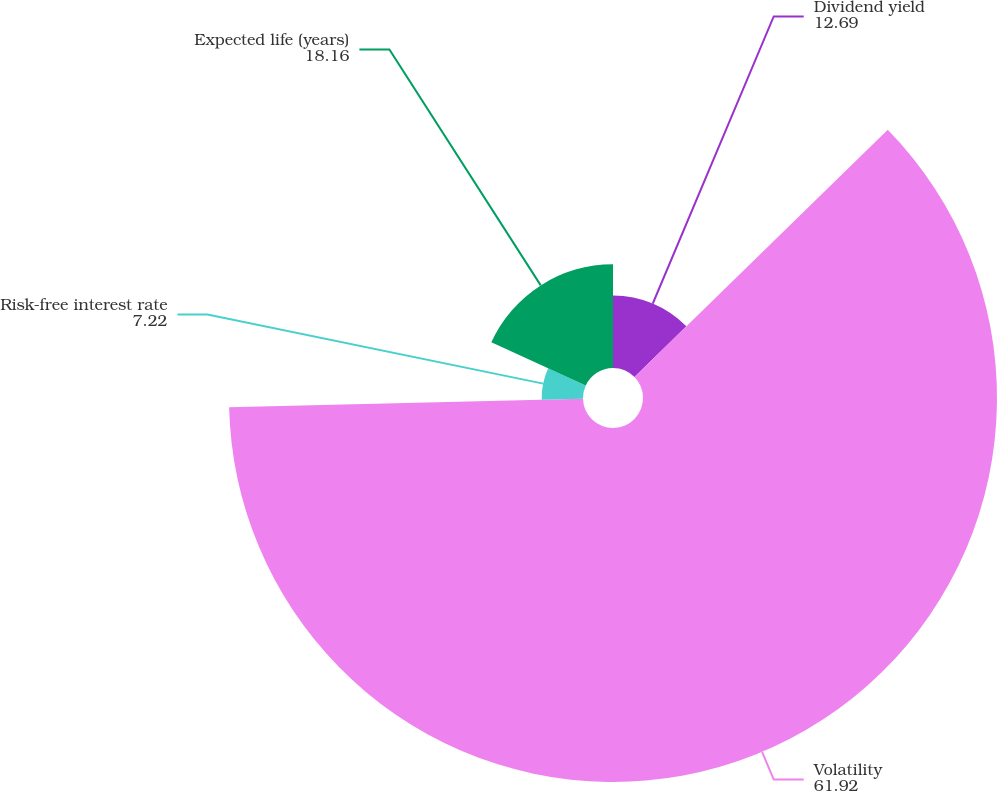Convert chart to OTSL. <chart><loc_0><loc_0><loc_500><loc_500><pie_chart><fcel>Dividend yield<fcel>Volatility<fcel>Risk-free interest rate<fcel>Expected life (years)<nl><fcel>12.69%<fcel>61.92%<fcel>7.22%<fcel>18.16%<nl></chart> 